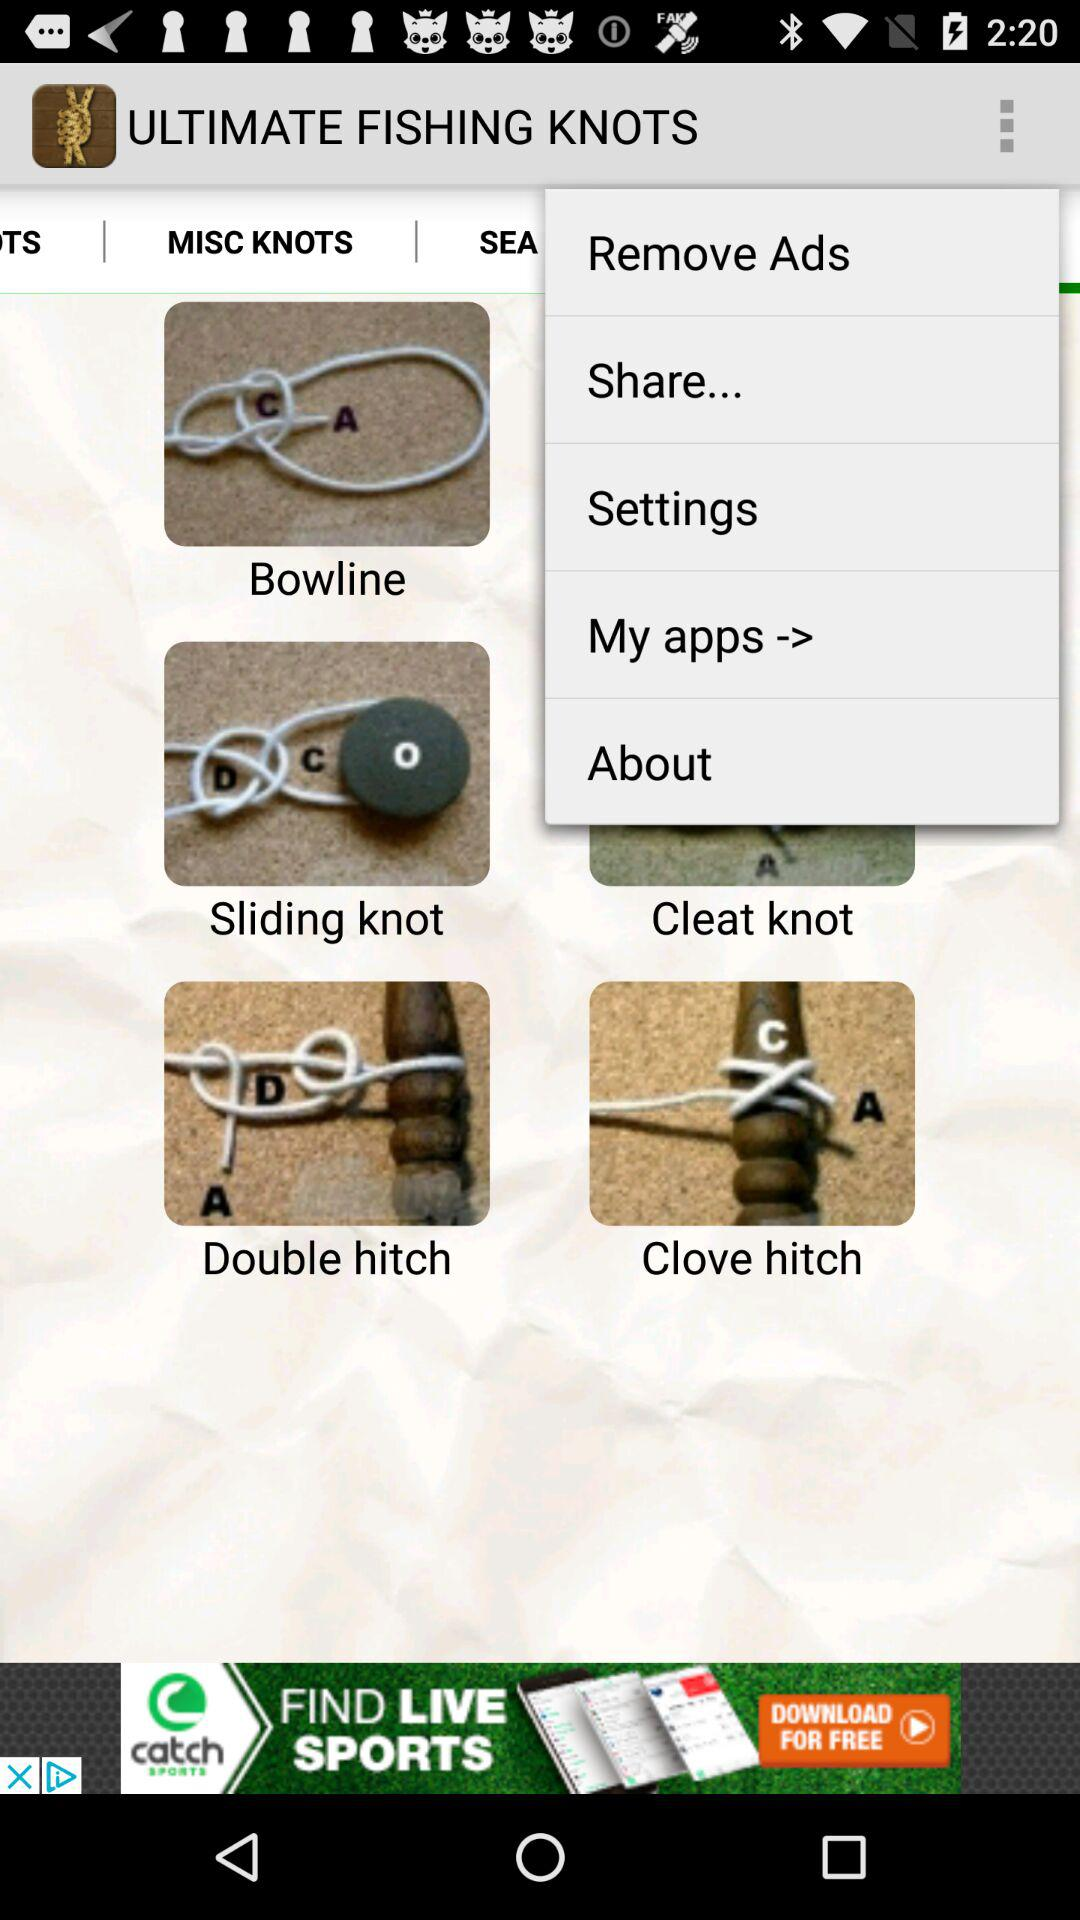What are the different types of knots? The different types of knots are "Bowline", "Sliding knot", "Cleat knot", "Double hitch" and "Clove hitch". 